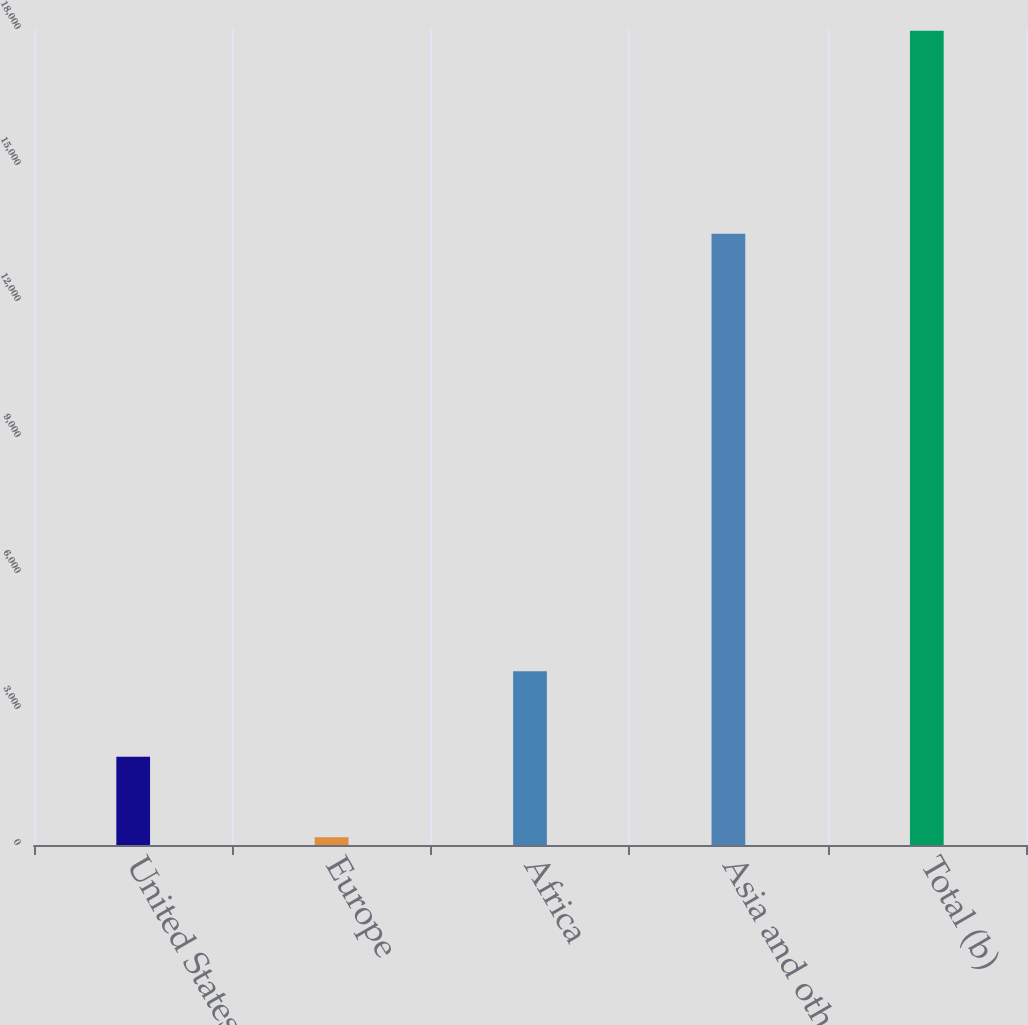<chart> <loc_0><loc_0><loc_500><loc_500><bar_chart><fcel>United States<fcel>Europe<fcel>Africa<fcel>Asia and other<fcel>Total (b)<nl><fcel>1948.5<fcel>169<fcel>3831<fcel>13483<fcel>17964<nl></chart> 